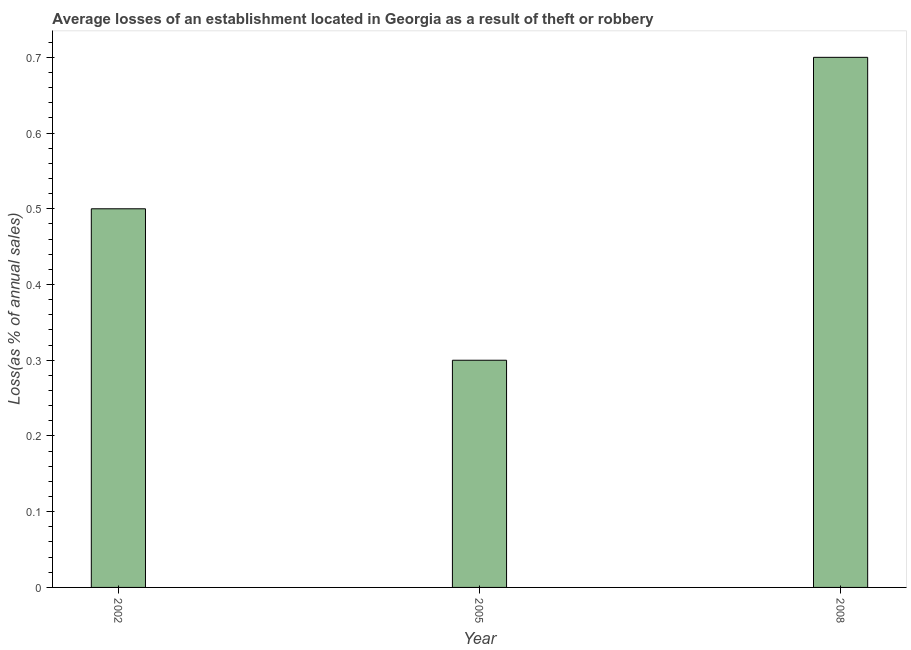What is the title of the graph?
Your answer should be compact. Average losses of an establishment located in Georgia as a result of theft or robbery. What is the label or title of the Y-axis?
Keep it short and to the point. Loss(as % of annual sales). What is the losses due to theft in 2002?
Make the answer very short. 0.5. Across all years, what is the maximum losses due to theft?
Offer a very short reply. 0.7. What is the difference between the losses due to theft in 2002 and 2005?
Your answer should be compact. 0.2. What is the average losses due to theft per year?
Make the answer very short. 0.5. In how many years, is the losses due to theft greater than 0.4 %?
Give a very brief answer. 2. What is the ratio of the losses due to theft in 2005 to that in 2008?
Make the answer very short. 0.43. Is the sum of the losses due to theft in 2005 and 2008 greater than the maximum losses due to theft across all years?
Provide a succinct answer. Yes. In how many years, is the losses due to theft greater than the average losses due to theft taken over all years?
Offer a very short reply. 1. Are all the bars in the graph horizontal?
Provide a succinct answer. No. How many years are there in the graph?
Keep it short and to the point. 3. Are the values on the major ticks of Y-axis written in scientific E-notation?
Your answer should be compact. No. What is the Loss(as % of annual sales) in 2008?
Keep it short and to the point. 0.7. What is the difference between the Loss(as % of annual sales) in 2002 and 2005?
Offer a terse response. 0.2. What is the difference between the Loss(as % of annual sales) in 2002 and 2008?
Your answer should be very brief. -0.2. What is the ratio of the Loss(as % of annual sales) in 2002 to that in 2005?
Provide a short and direct response. 1.67. What is the ratio of the Loss(as % of annual sales) in 2002 to that in 2008?
Keep it short and to the point. 0.71. What is the ratio of the Loss(as % of annual sales) in 2005 to that in 2008?
Make the answer very short. 0.43. 